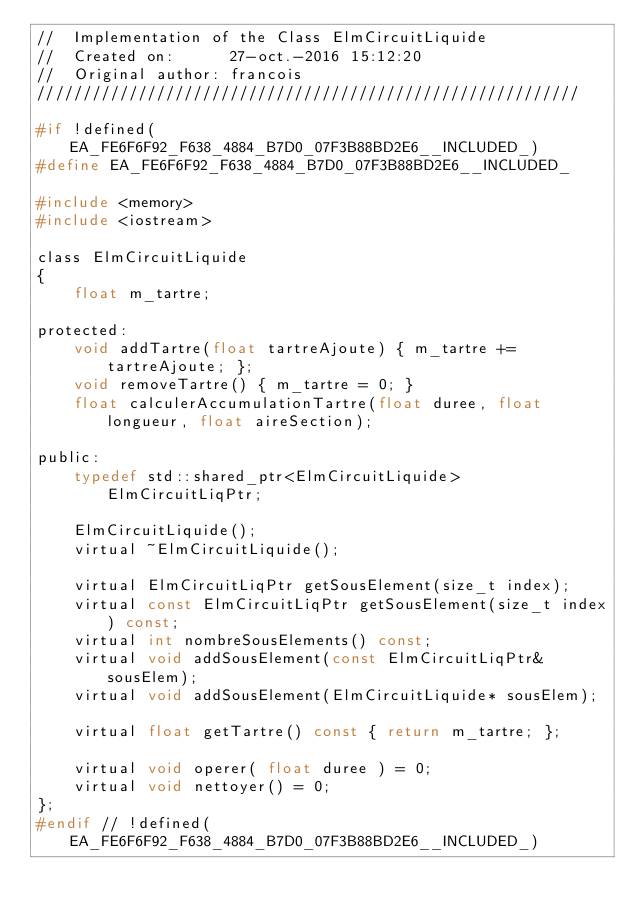Convert code to text. <code><loc_0><loc_0><loc_500><loc_500><_C_>//  Implementation of the Class ElmCircuitLiquide
//  Created on:      27-oct.-2016 15:12:20
//  Original author: francois
///////////////////////////////////////////////////////////

#if !defined(EA_FE6F6F92_F638_4884_B7D0_07F3B88BD2E6__INCLUDED_)
#define EA_FE6F6F92_F638_4884_B7D0_07F3B88BD2E6__INCLUDED_

#include <memory>
#include <iostream>

class ElmCircuitLiquide
{
	float m_tartre;

protected:
	void addTartre(float tartreAjoute) { m_tartre += tartreAjoute; };
	void removeTartre() { m_tartre = 0; }
	float calculerAccumulationTartre(float duree, float longueur, float aireSection);

public:
	typedef std::shared_ptr<ElmCircuitLiquide> ElmCircuitLiqPtr;

	ElmCircuitLiquide();
	virtual ~ElmCircuitLiquide();

	virtual ElmCircuitLiqPtr getSousElement(size_t index);
	virtual const ElmCircuitLiqPtr getSousElement(size_t index) const;
	virtual int nombreSousElements() const;
	virtual void addSousElement(const ElmCircuitLiqPtr& sousElem);
	virtual void addSousElement(ElmCircuitLiquide* sousElem);

	virtual float getTartre() const { return m_tartre; };
	
	virtual void operer( float duree ) = 0;
	virtual void nettoyer() = 0;
};
#endif // !defined(EA_FE6F6F92_F638_4884_B7D0_07F3B88BD2E6__INCLUDED_)
</code> 